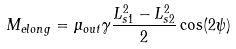<formula> <loc_0><loc_0><loc_500><loc_500>M _ { e l o n g } = \mu _ { o u t } \gamma \frac { L _ { s 1 } ^ { 2 } - L _ { s 2 } ^ { 2 } } { 2 } \cos ( 2 \psi )</formula> 